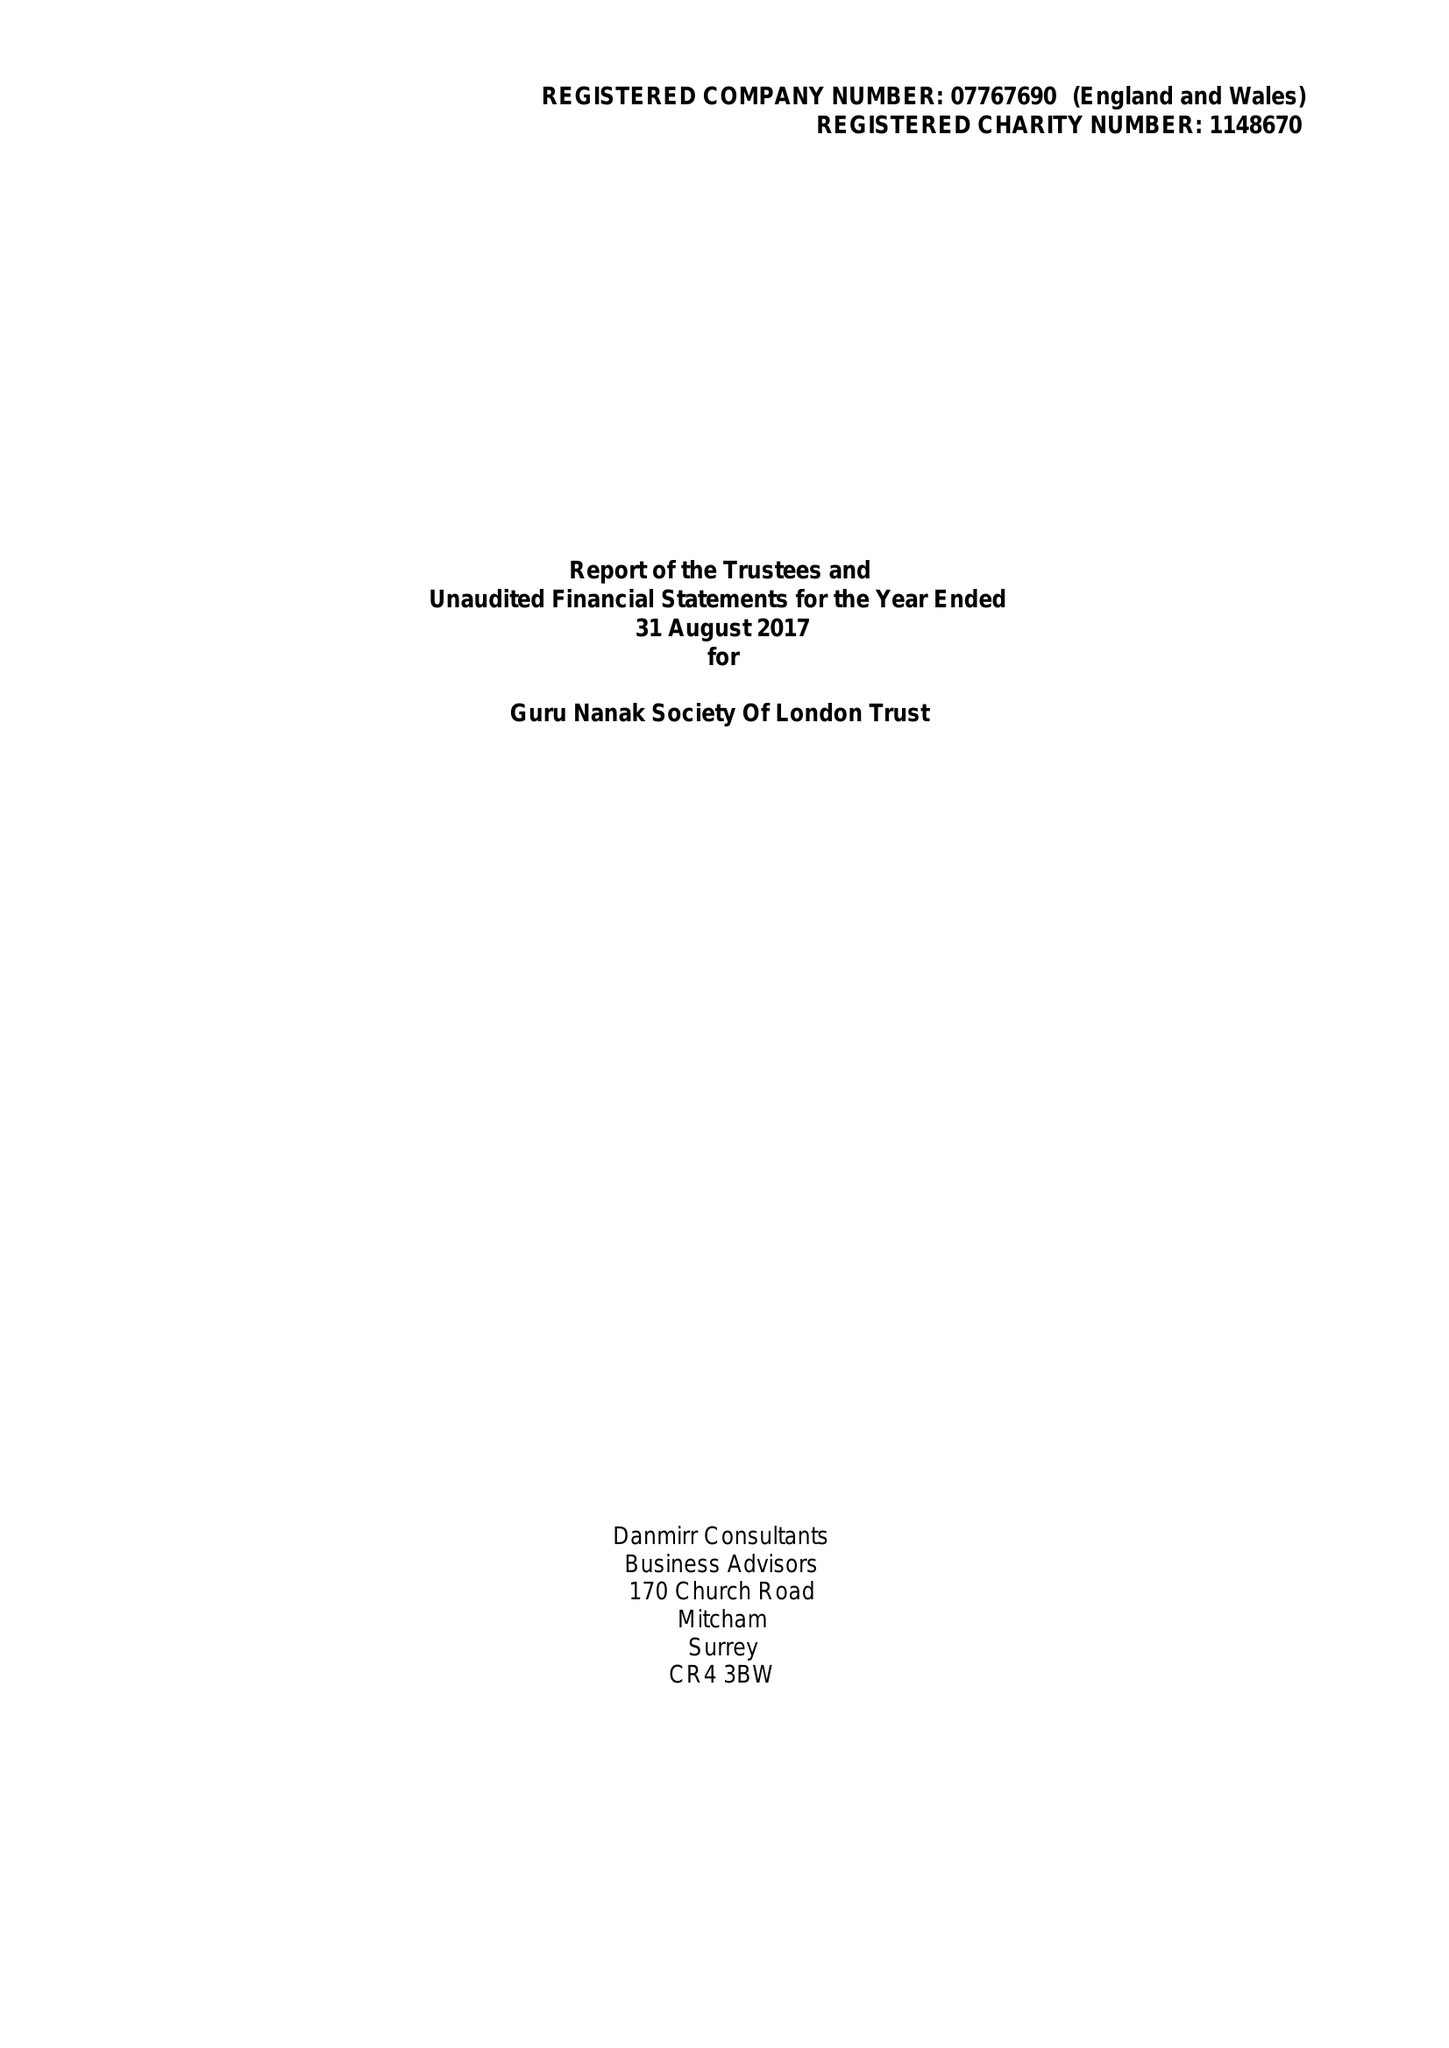What is the value for the address__street_line?
Answer the question using a single word or phrase. BRIDGE ROAD 